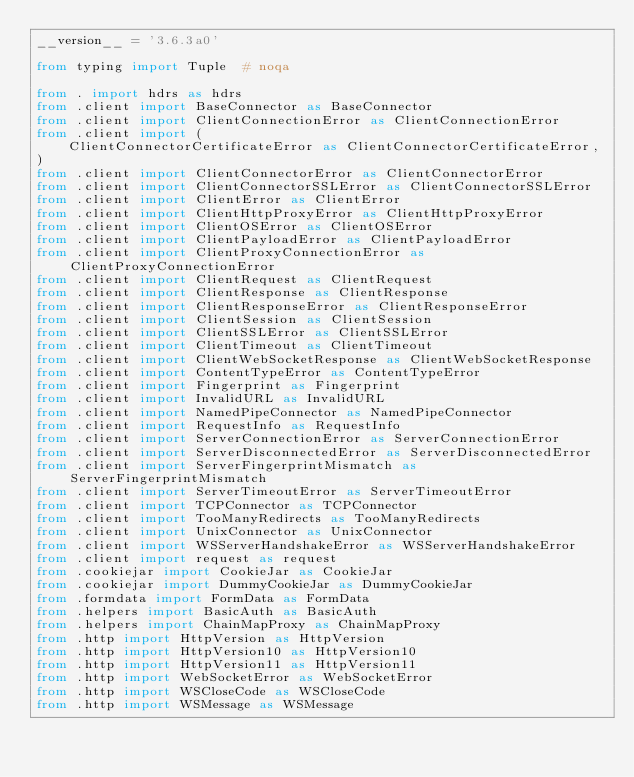Convert code to text. <code><loc_0><loc_0><loc_500><loc_500><_Python_>__version__ = '3.6.3a0'

from typing import Tuple  # noqa

from . import hdrs as hdrs
from .client import BaseConnector as BaseConnector
from .client import ClientConnectionError as ClientConnectionError
from .client import (
    ClientConnectorCertificateError as ClientConnectorCertificateError,
)
from .client import ClientConnectorError as ClientConnectorError
from .client import ClientConnectorSSLError as ClientConnectorSSLError
from .client import ClientError as ClientError
from .client import ClientHttpProxyError as ClientHttpProxyError
from .client import ClientOSError as ClientOSError
from .client import ClientPayloadError as ClientPayloadError
from .client import ClientProxyConnectionError as ClientProxyConnectionError
from .client import ClientRequest as ClientRequest
from .client import ClientResponse as ClientResponse
from .client import ClientResponseError as ClientResponseError
from .client import ClientSession as ClientSession
from .client import ClientSSLError as ClientSSLError
from .client import ClientTimeout as ClientTimeout
from .client import ClientWebSocketResponse as ClientWebSocketResponse
from .client import ContentTypeError as ContentTypeError
from .client import Fingerprint as Fingerprint
from .client import InvalidURL as InvalidURL
from .client import NamedPipeConnector as NamedPipeConnector
from .client import RequestInfo as RequestInfo
from .client import ServerConnectionError as ServerConnectionError
from .client import ServerDisconnectedError as ServerDisconnectedError
from .client import ServerFingerprintMismatch as ServerFingerprintMismatch
from .client import ServerTimeoutError as ServerTimeoutError
from .client import TCPConnector as TCPConnector
from .client import TooManyRedirects as TooManyRedirects
from .client import UnixConnector as UnixConnector
from .client import WSServerHandshakeError as WSServerHandshakeError
from .client import request as request
from .cookiejar import CookieJar as CookieJar
from .cookiejar import DummyCookieJar as DummyCookieJar
from .formdata import FormData as FormData
from .helpers import BasicAuth as BasicAuth
from .helpers import ChainMapProxy as ChainMapProxy
from .http import HttpVersion as HttpVersion
from .http import HttpVersion10 as HttpVersion10
from .http import HttpVersion11 as HttpVersion11
from .http import WebSocketError as WebSocketError
from .http import WSCloseCode as WSCloseCode
from .http import WSMessage as WSMessage</code> 